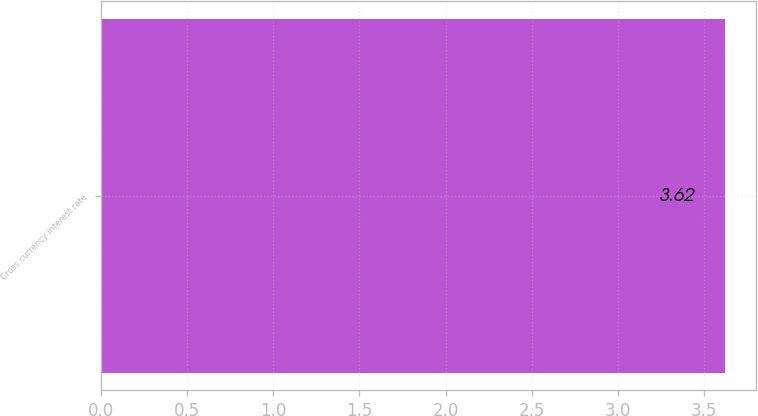Convert chart to OTSL. <chart><loc_0><loc_0><loc_500><loc_500><bar_chart><fcel>Cross currency interest rate<nl><fcel>3.62<nl></chart> 